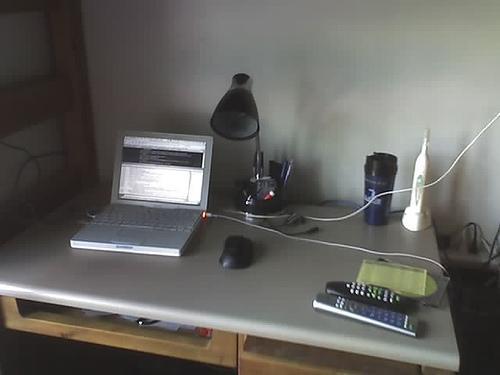How many remote controls are here?
Give a very brief answer. 2. 